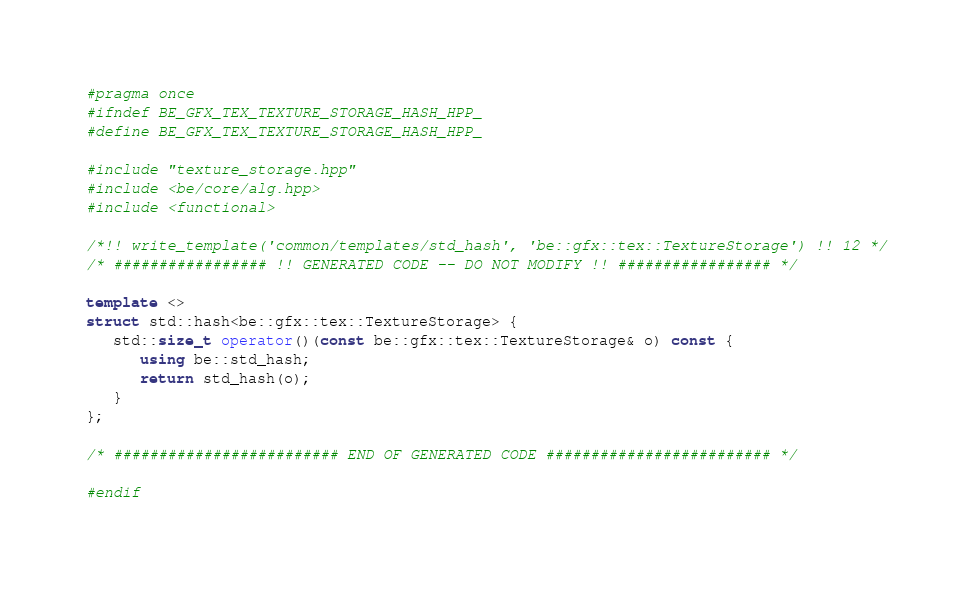<code> <loc_0><loc_0><loc_500><loc_500><_C++_>#pragma once
#ifndef BE_GFX_TEX_TEXTURE_STORAGE_HASH_HPP_
#define BE_GFX_TEX_TEXTURE_STORAGE_HASH_HPP_

#include "texture_storage.hpp"
#include <be/core/alg.hpp>
#include <functional>

/*!! write_template('common/templates/std_hash', 'be::gfx::tex::TextureStorage') !! 12 */
/* ################# !! GENERATED CODE -- DO NOT MODIFY !! ################# */

template <>
struct std::hash<be::gfx::tex::TextureStorage> {
   std::size_t operator()(const be::gfx::tex::TextureStorage& o) const {
      using be::std_hash;
      return std_hash(o);
   }
};

/* ######################### END OF GENERATED CODE ######################### */

#endif
</code> 